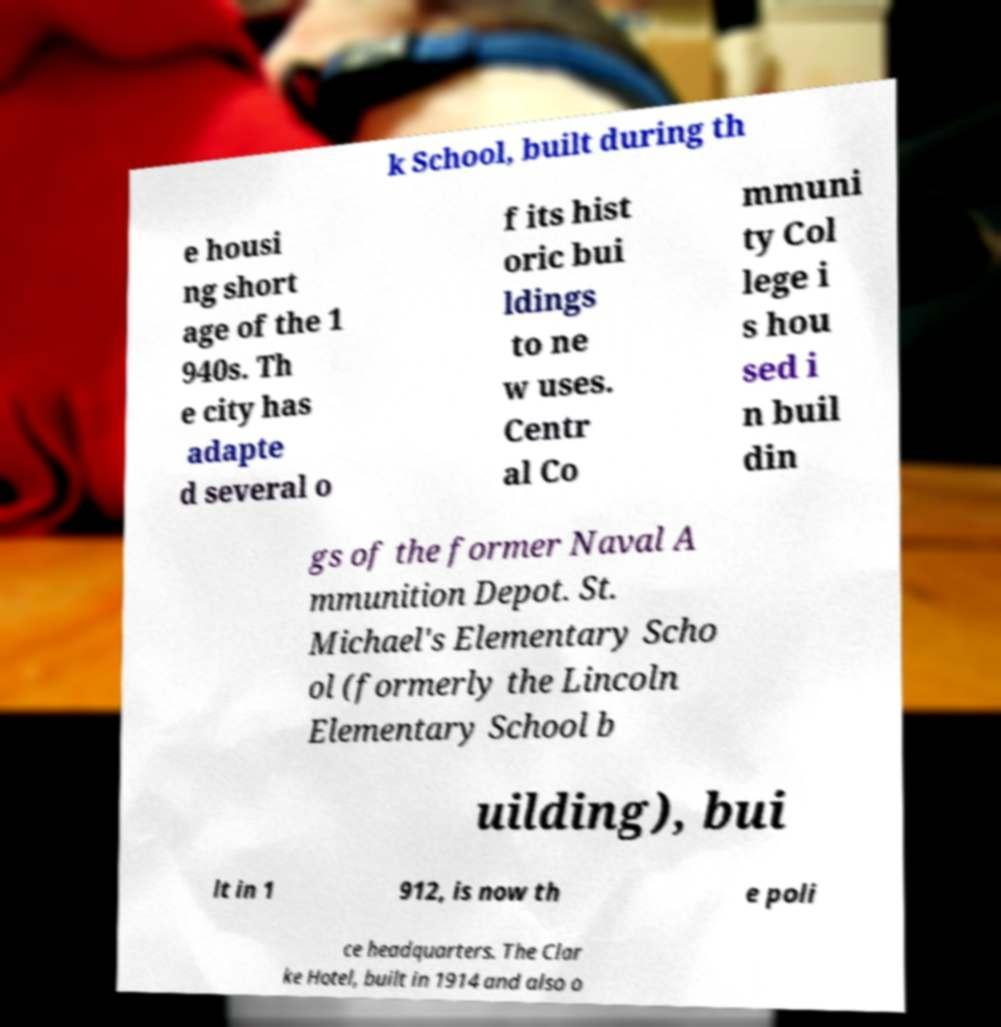Please identify and transcribe the text found in this image. k School, built during th e housi ng short age of the 1 940s. Th e city has adapte d several o f its hist oric bui ldings to ne w uses. Centr al Co mmuni ty Col lege i s hou sed i n buil din gs of the former Naval A mmunition Depot. St. Michael's Elementary Scho ol (formerly the Lincoln Elementary School b uilding), bui lt in 1 912, is now th e poli ce headquarters. The Clar ke Hotel, built in 1914 and also o 